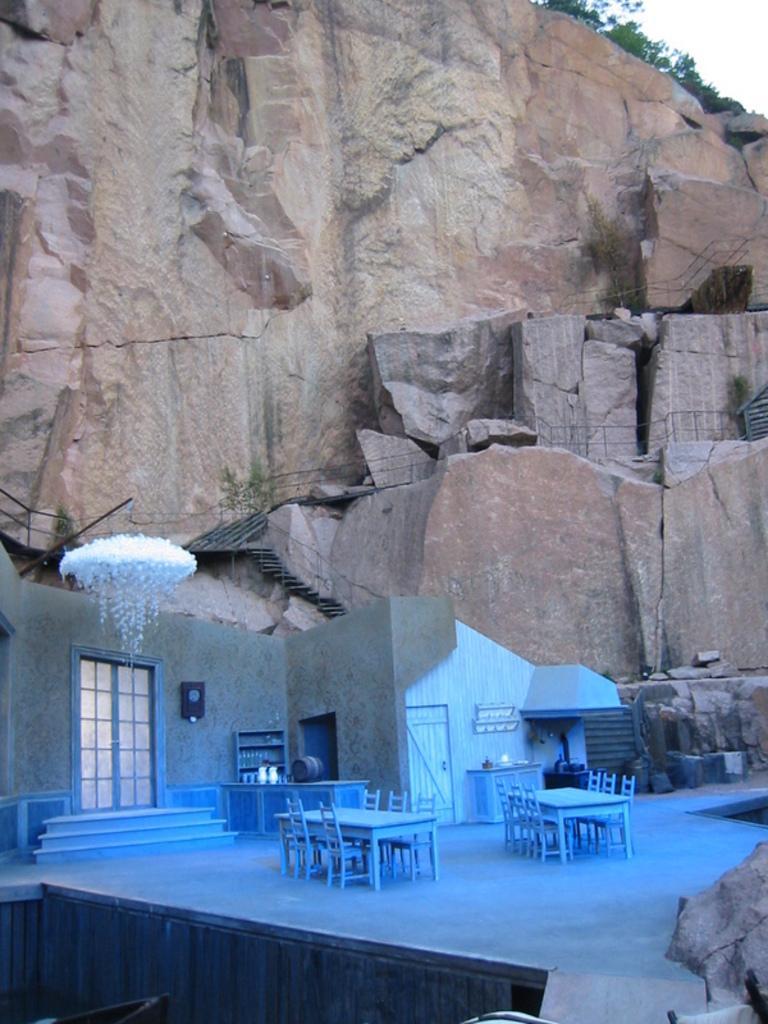Can you describe this image briefly? In the image on the floor there are chairs, tables, doors, walls and cupboards. And also there is a handmade cloud. Behind them there are is a hill with rocks and on the rocks there are steps with railing. At the top of the image there are trees. 